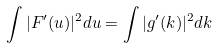<formula> <loc_0><loc_0><loc_500><loc_500>\int | F ^ { \prime } ( u ) | ^ { 2 } d u = \int | g ^ { \prime } ( k ) | ^ { 2 } d k</formula> 